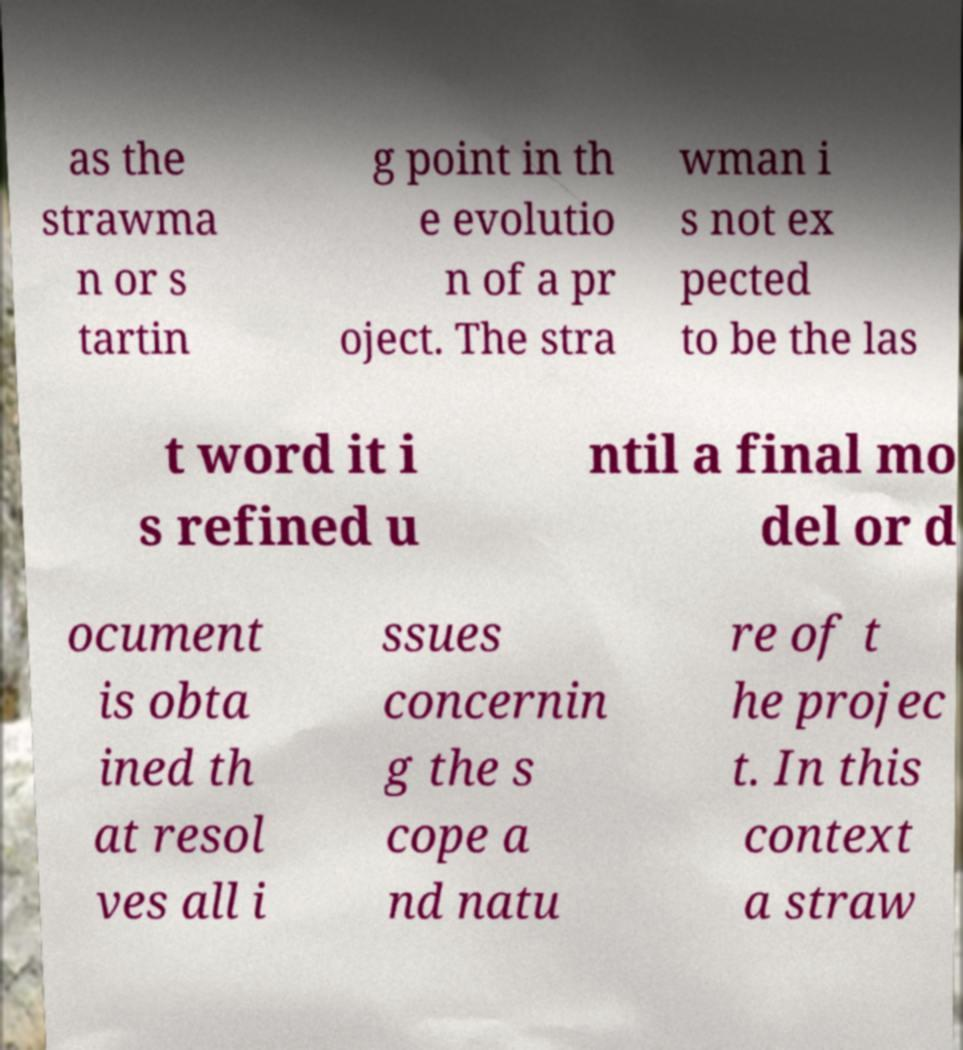I need the written content from this picture converted into text. Can you do that? as the strawma n or s tartin g point in th e evolutio n of a pr oject. The stra wman i s not ex pected to be the las t word it i s refined u ntil a final mo del or d ocument is obta ined th at resol ves all i ssues concernin g the s cope a nd natu re of t he projec t. In this context a straw 